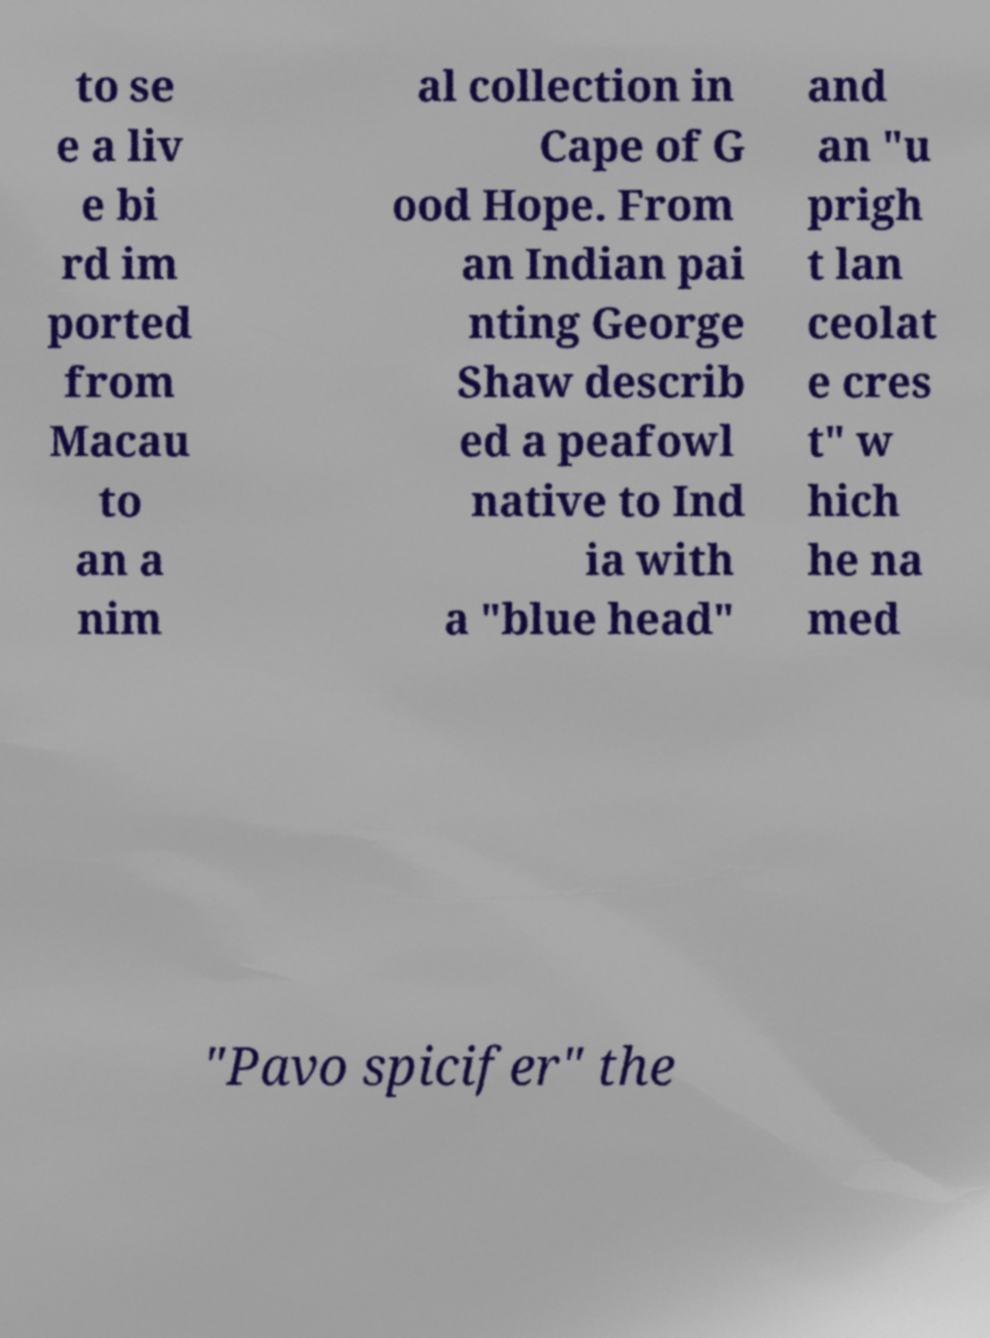Can you accurately transcribe the text from the provided image for me? to se e a liv e bi rd im ported from Macau to an a nim al collection in Cape of G ood Hope. From an Indian pai nting George Shaw describ ed a peafowl native to Ind ia with a "blue head" and an "u prigh t lan ceolat e cres t" w hich he na med "Pavo spicifer" the 